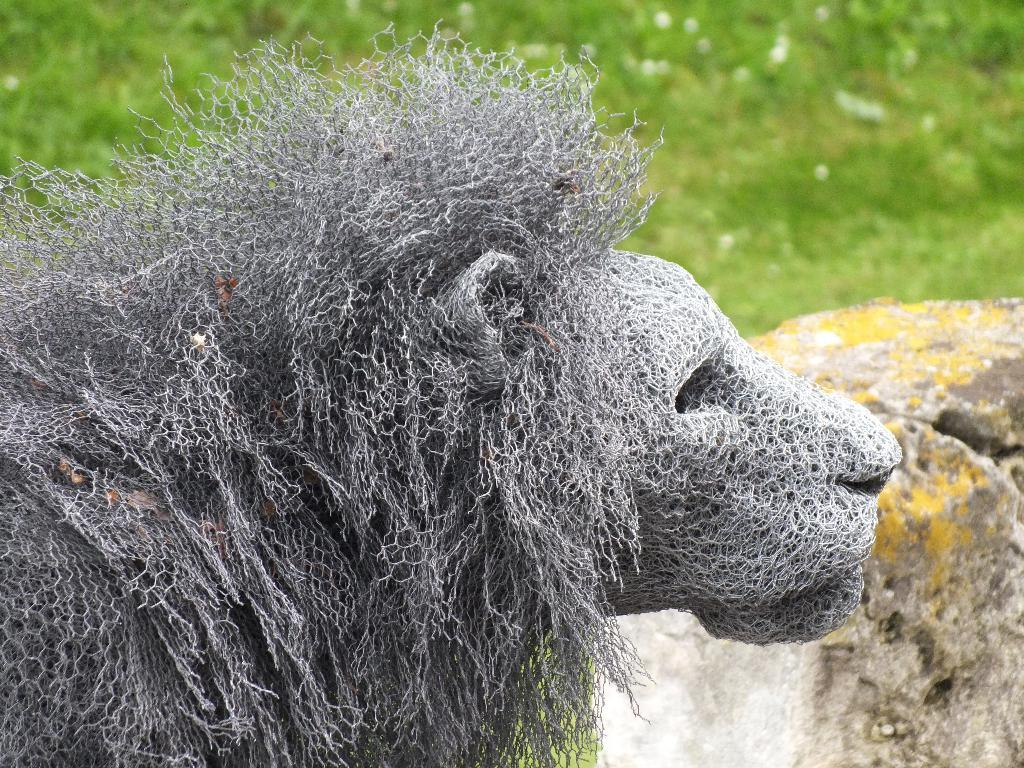What type of artwork is featured in the image? There is a sculpture of an animal in the image. What other object can be seen on the right side of the image? There is a rock on the right side of the image. What type of environment is visible in the background of the image? The background of the image includes grassland. What type of juice is being served by the secretary in the image? There is no secretary or juice present in the image. The image features a sculpture of an animal, a rock, and a grassland background. 